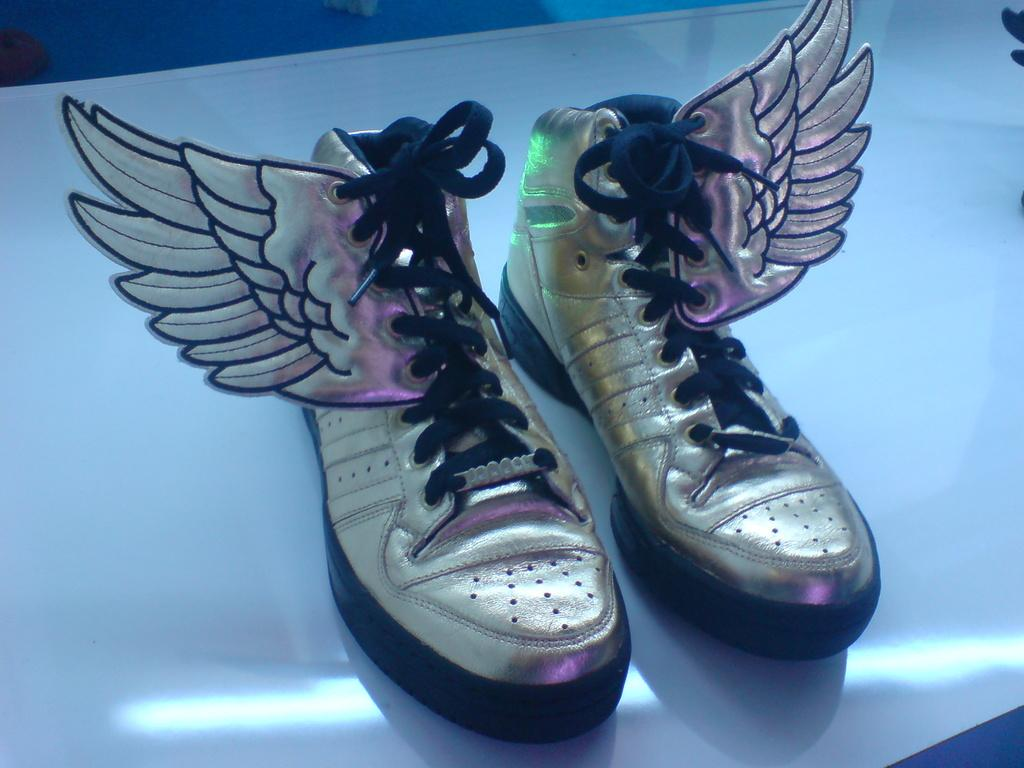What objects are in the image? There are shoes in the image. Where are the shoes located? The shoes are on a platform. What type of plant can be seen growing on the street in the image? There is no plant or street present in the image; it only features shoes on a platform. 